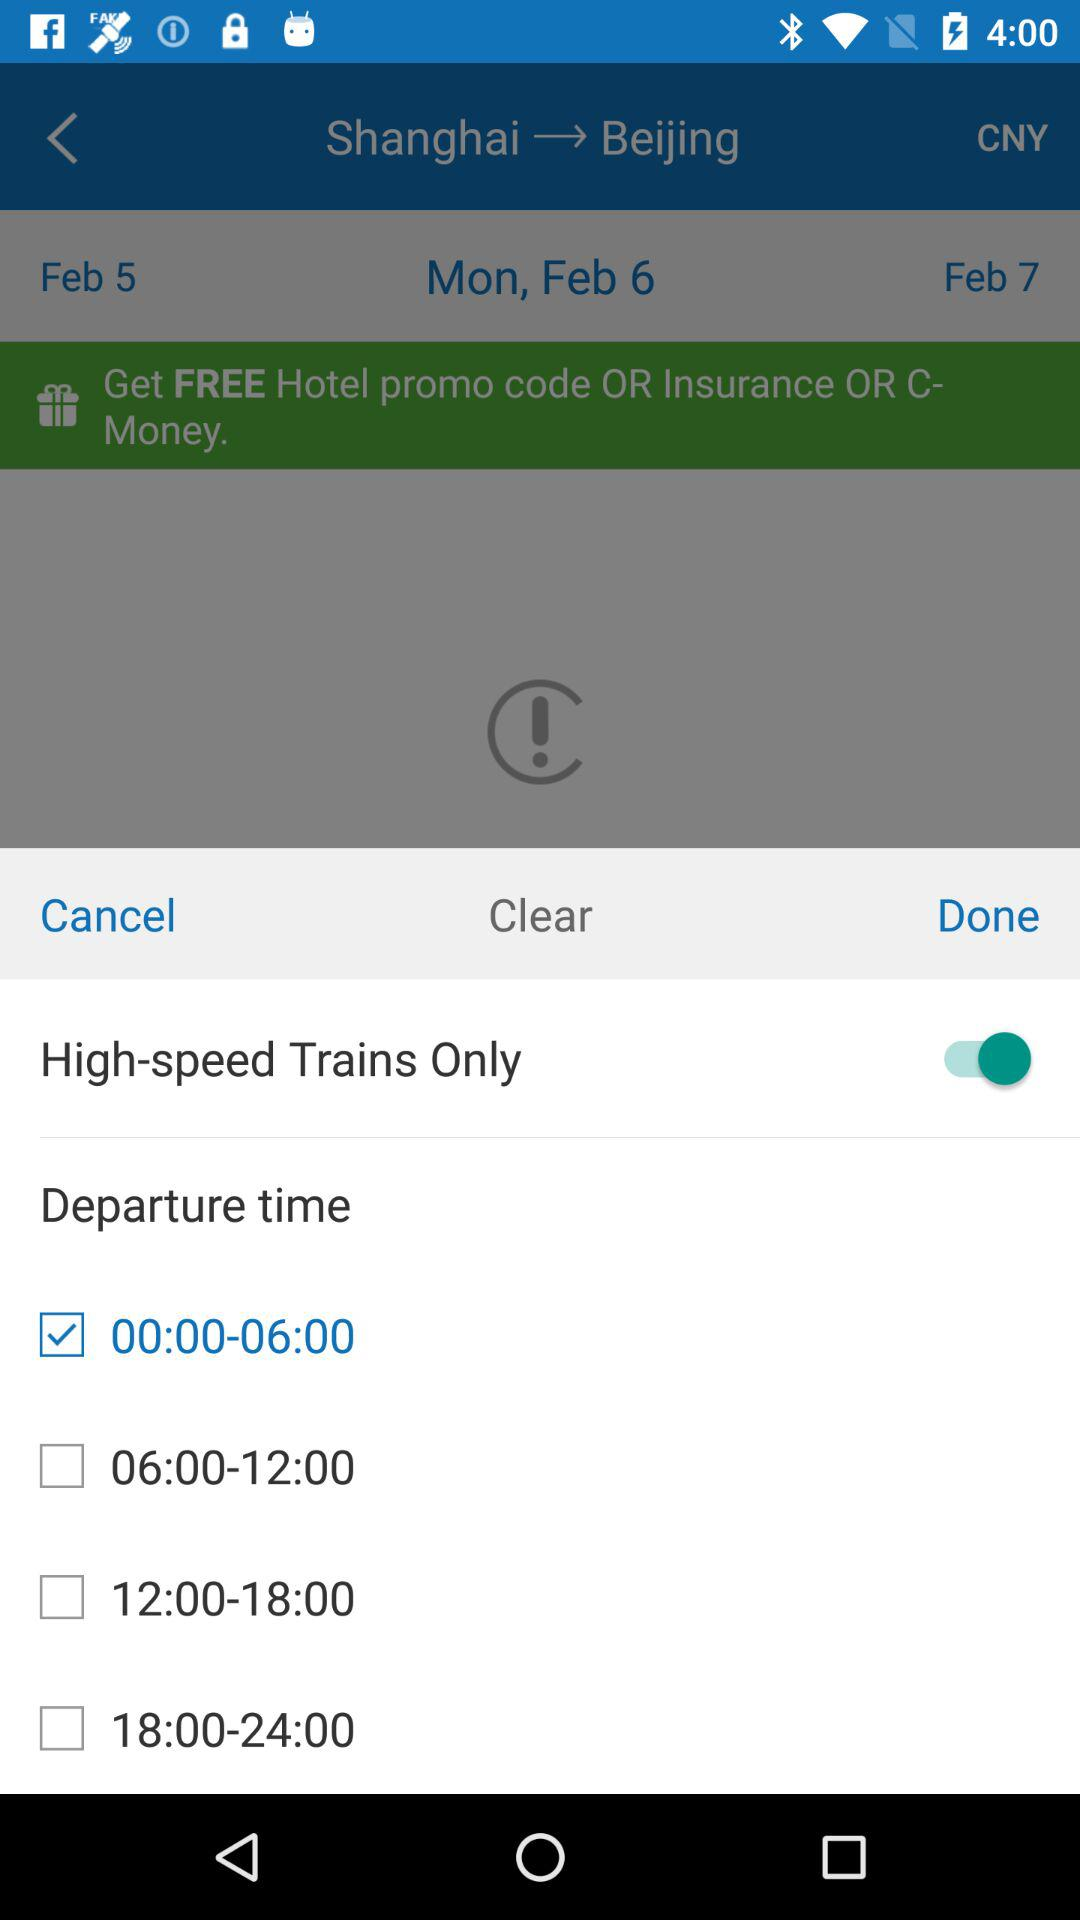What is the status of "High-speed Trains Only"? The status of "High-speed Trains Only" is "on". 